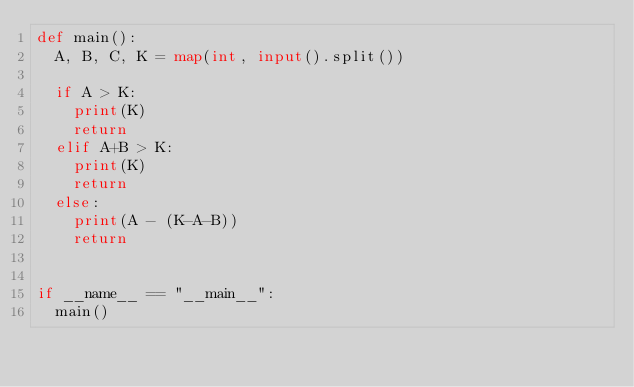Convert code to text. <code><loc_0><loc_0><loc_500><loc_500><_Python_>def main():
  A, B, C, K = map(int, input().split())

  if A > K:
    print(K)
    return
  elif A+B > K:
    print(K)
    return
  else:
    print(A - (K-A-B))
    return


if __name__ == "__main__":
  main()</code> 